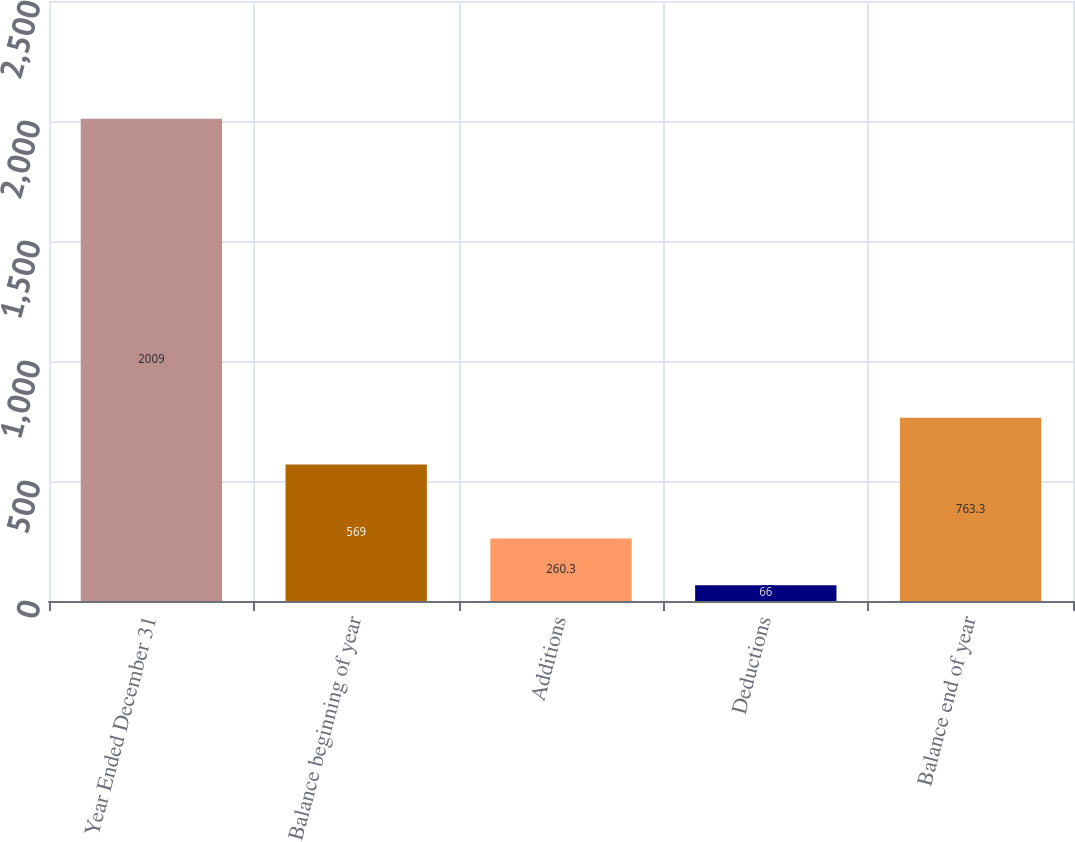Convert chart to OTSL. <chart><loc_0><loc_0><loc_500><loc_500><bar_chart><fcel>Year Ended December 31<fcel>Balance beginning of year<fcel>Additions<fcel>Deductions<fcel>Balance end of year<nl><fcel>2009<fcel>569<fcel>260.3<fcel>66<fcel>763.3<nl></chart> 